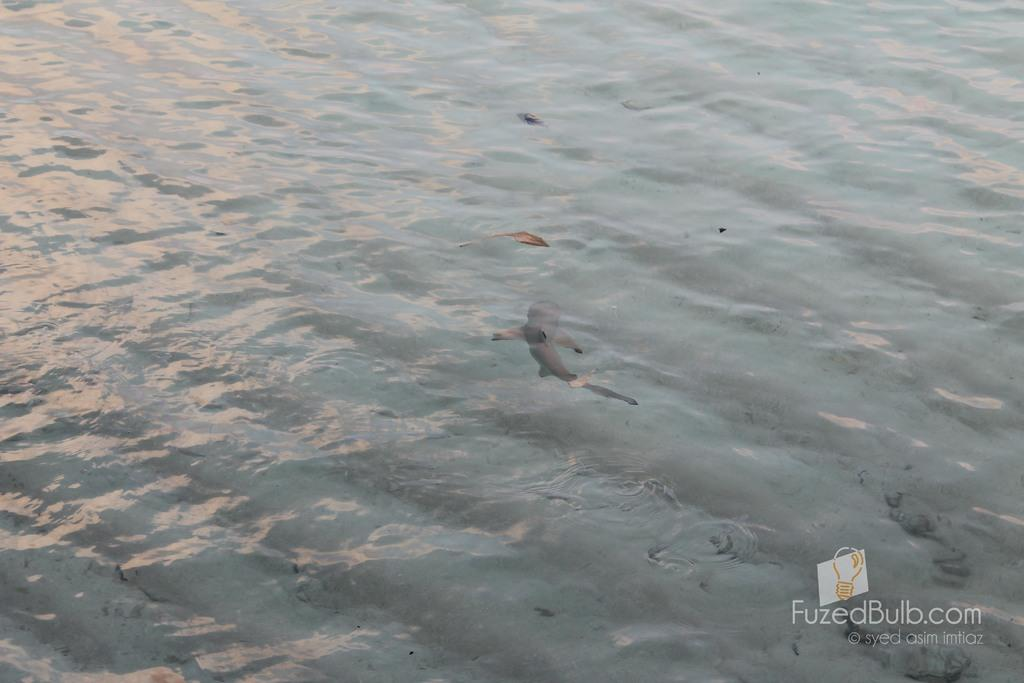What type of animal is in the image? There is a fish in the image. Where is the fish located? The fish is in the water. What does the fish's grandfather say about the cattle in the image? There is no mention of a grandfather or cattle in the image; it only features a fish in the water. 